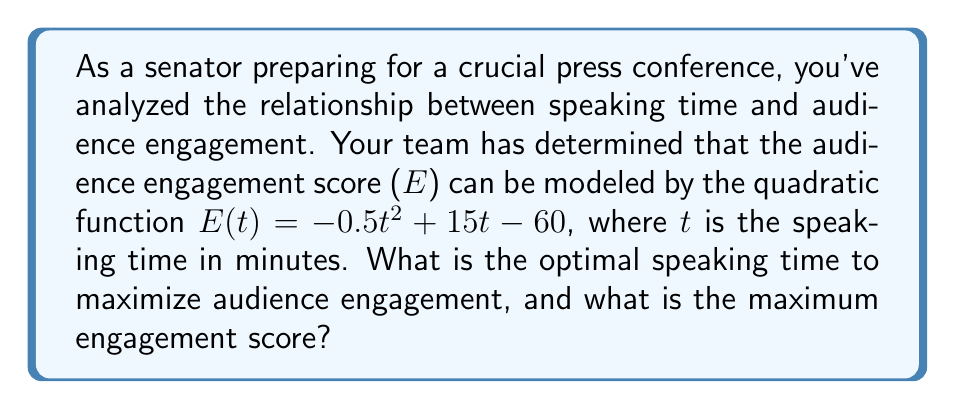Can you answer this question? To find the optimal speaking time and maximum engagement score, we need to follow these steps:

1. Recognize that this is a quadratic function in the form $f(x) = ax^2 + bx + c$, where:
   $a = -0.5$
   $b = 15$
   $c = -60$

2. The vertex of a parabola represents the maximum point for a downward-facing parabola (where $a < 0$). The x-coordinate of the vertex gives us the optimal speaking time, and the y-coordinate gives us the maximum engagement score.

3. To find the x-coordinate of the vertex, we use the formula: $x = -\frac{b}{2a}$
   
   $t_{optimal} = -\frac{15}{2(-0.5)} = \frac{15}{1} = 15$ minutes

4. To find the maximum engagement score, we substitute the optimal time into the original function:

   $E(15) = -0.5(15)^2 + 15(15) - 60$
   $= -0.5(225) + 225 - 60$
   $= -112.5 + 225 - 60$
   $= 52.5$

Therefore, the optimal speaking time is 15 minutes, and the maximum engagement score is 52.5.
Answer: 15 minutes; 52.5 